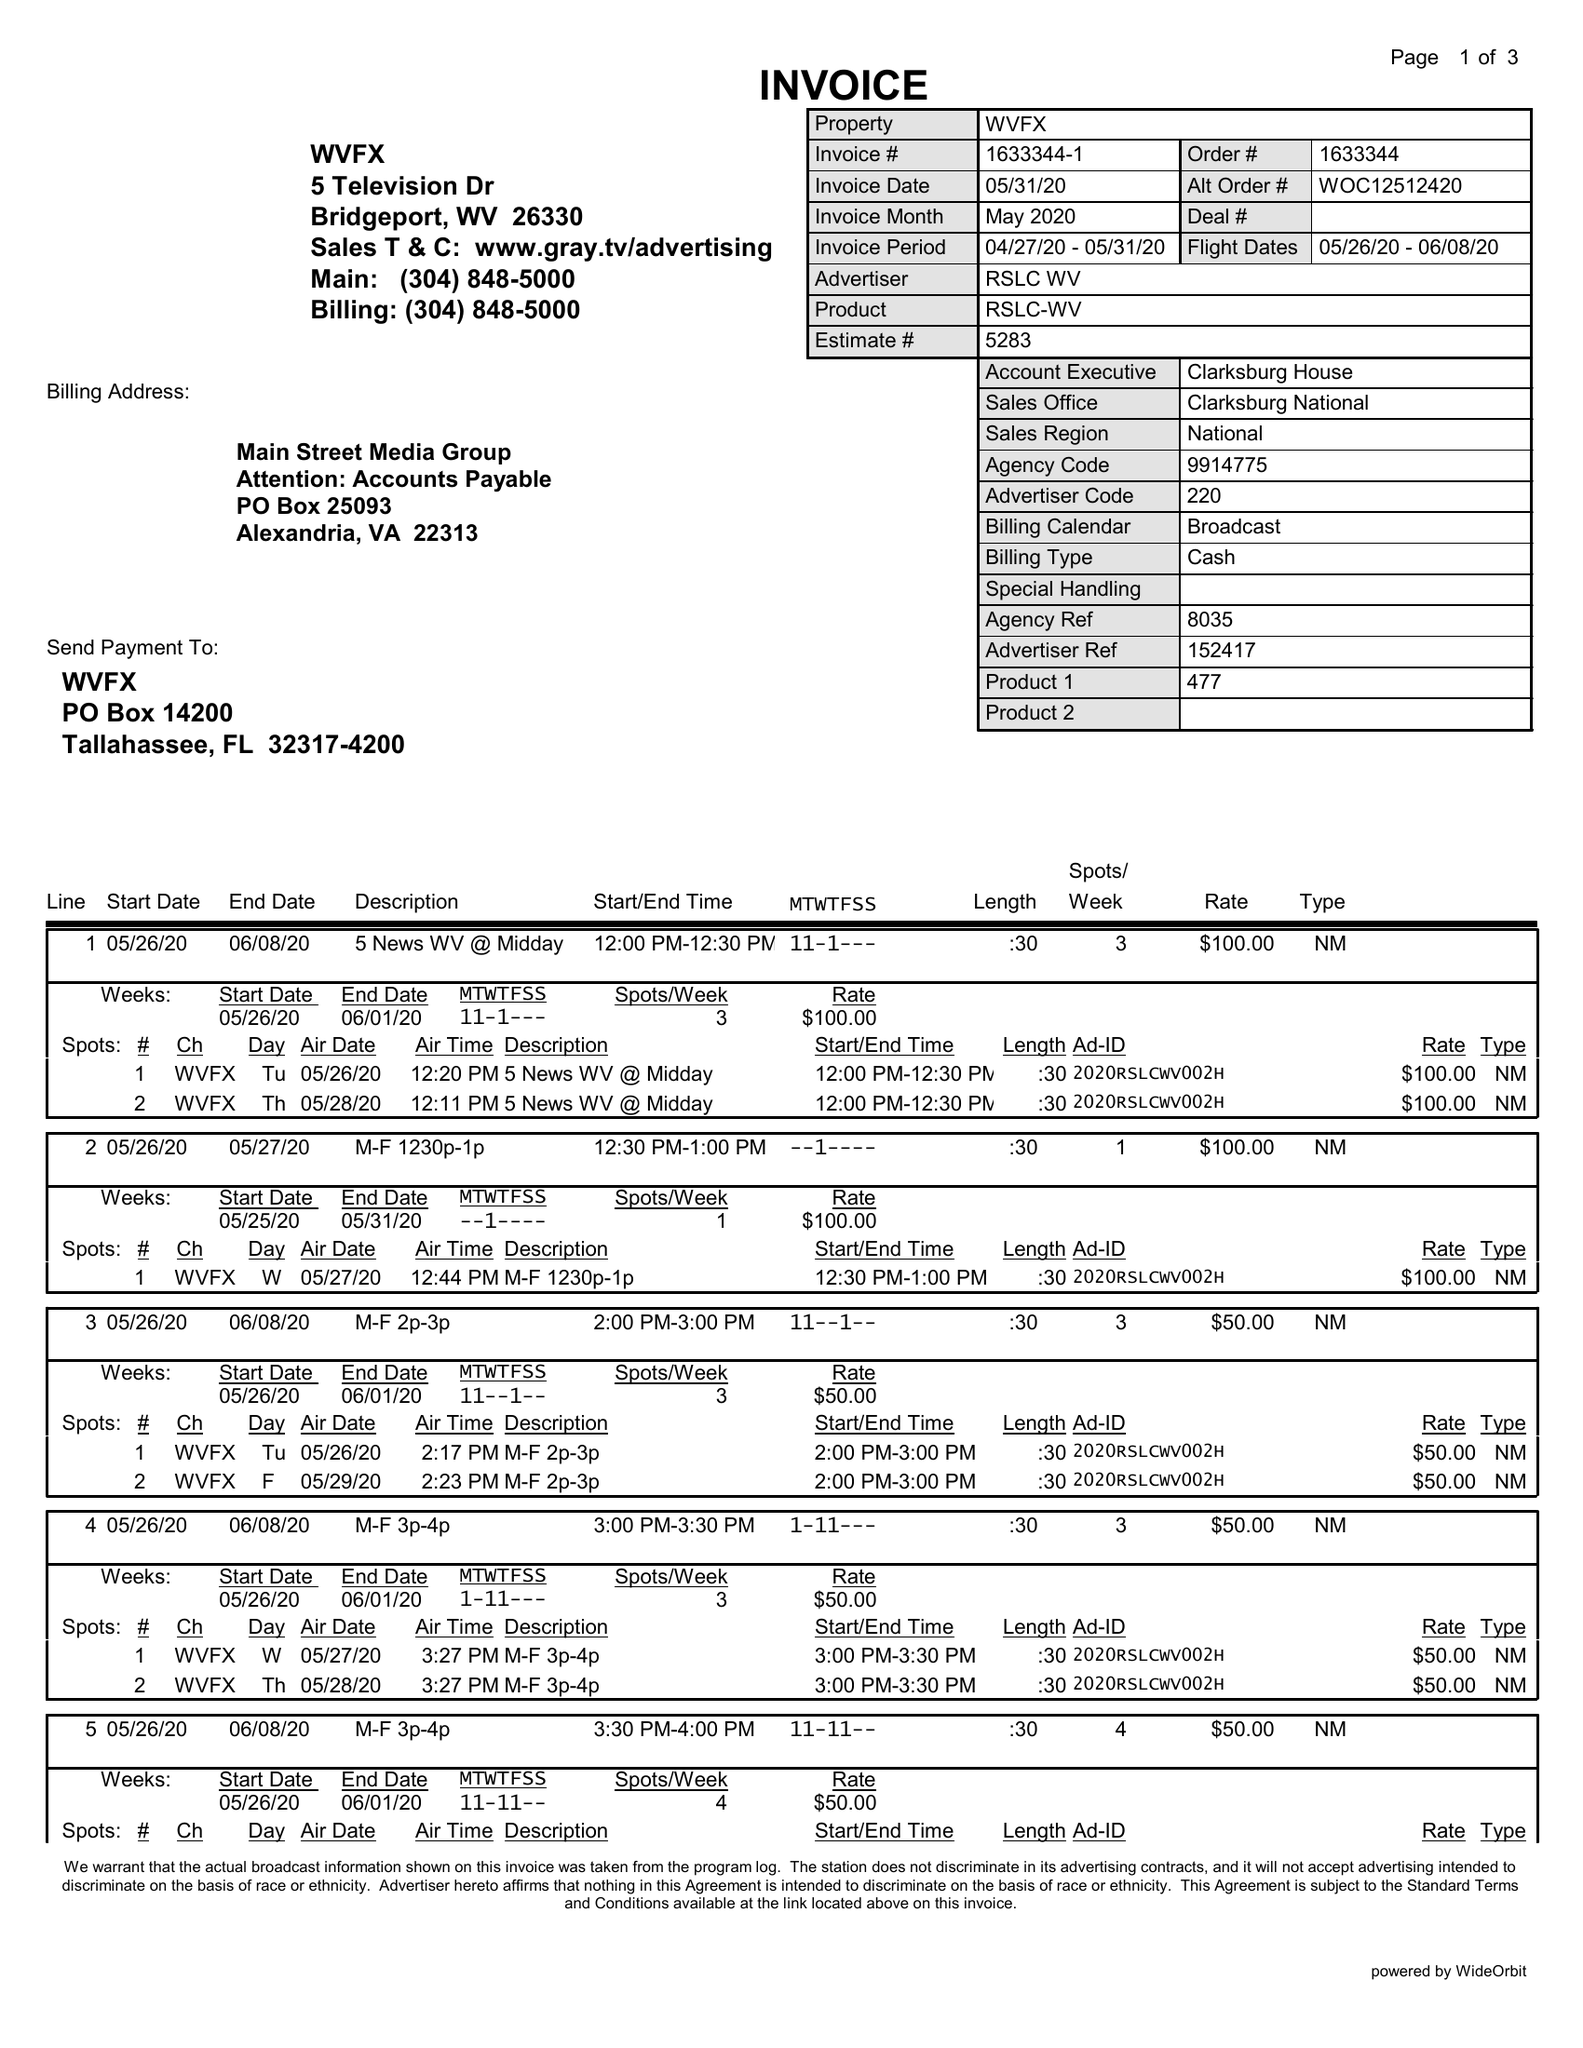What is the value for the advertiser?
Answer the question using a single word or phrase. RSLC WV 